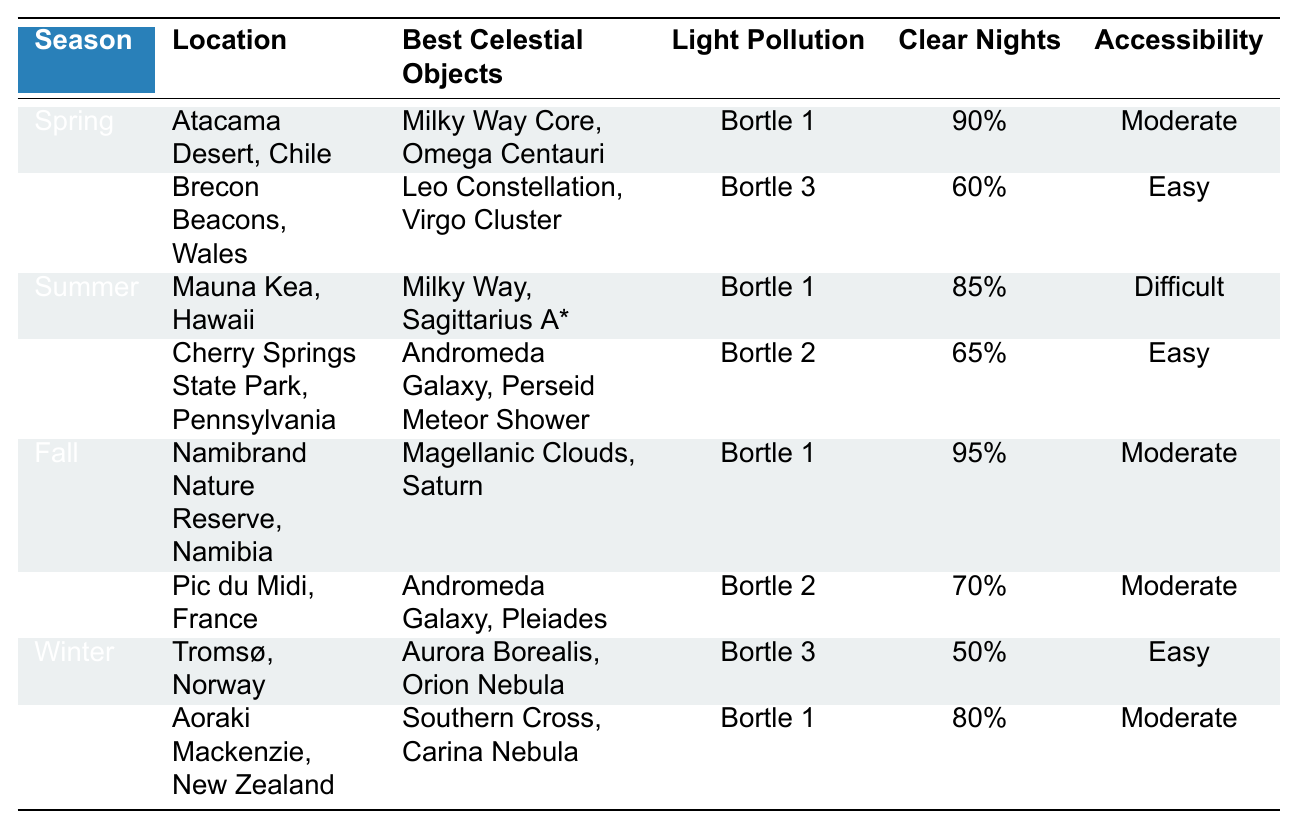What is the best location for astrophotography in spring? According to the table, the two locations for spring are the Atacama Desert in Chile and the Brecon Beacons in Wales. The Atacama Desert has the best conditions with a light pollution level of Bortle 1 and 90% clear nights.
Answer: Atacama Desert, Chile Which location has the highest average clear nights? The Namibrand Nature Reserve in Namibia has the highest average clear nights at 95%. This can be determined by looking through the "Average Clear Nights" column for each location.
Answer: Namibrand Nature Reserve, Namibia Is the Milky Way visible in summer? Yes, the table indicates that the Milky Way is visible at Mauna Kea in Hawaii during summer, showing that it is indeed among the best celestial objects for astrophotography in that season.
Answer: Yes Among the locations listed, which has the least light pollution? The least light pollution is in the Atacama Desert, Chile, which has a light pollution level of Bortle 1. This is referenced in the "Light Pollution Level" column of the table.
Answer: Atacama Desert, Chile How many locations are listed for fall, and what are they? There are two locations listed for fall: Namibrand Nature Reserve in Namibia and Pic du Midi in France. This is found by counting the entries under the "Fall" season.
Answer: 2 locations: Namibrand Nature Reserve, Namibia and Pic du Midi, France What is the average light pollution level of the spring locations? The light pollution levels for spring are Bortle 1 for Atacama Desert and Bortle 3 for Brecon Beacons. To find the average, assign values (Bortle 1 = 1, Bortle 3 = 3) and calculate (1 + 3)/2 = 2, which corresponds to Bortle 2.
Answer: Bortle 2 Which location has both easy accessibility and high clear nights? The Cherry Springs State Park in Pennsylvania has easy accessibility and an average of 65% clear nights. This is shown in the "Accessibility" and "Average Clear Nights" columns.
Answer: Cherry Springs State Park, Pennsylvania Where can you observe the Aurora Borealis? The Aurora Borealis can be observed in Tromsø, Norway during winter, as indicated by the celestial objects listed for that location in the table.
Answer: Tromsø, Norway What season provides the least average clear nights? Winter provides the least average clear nights with Tromsø, Norway having 50% and Aoraki Mackenzie, New Zealand having 80%. The lower of the two is Tromsø.
Answer: Winter Which season has two locations listed with Bortle 2 light pollution? Fall has two locations listed with Bortle 2 light pollution: Pic du Midi in France and Cherry Springs State Park in Pennsylvania. This can be seen in the respective entries of the table.
Answer: Fall 